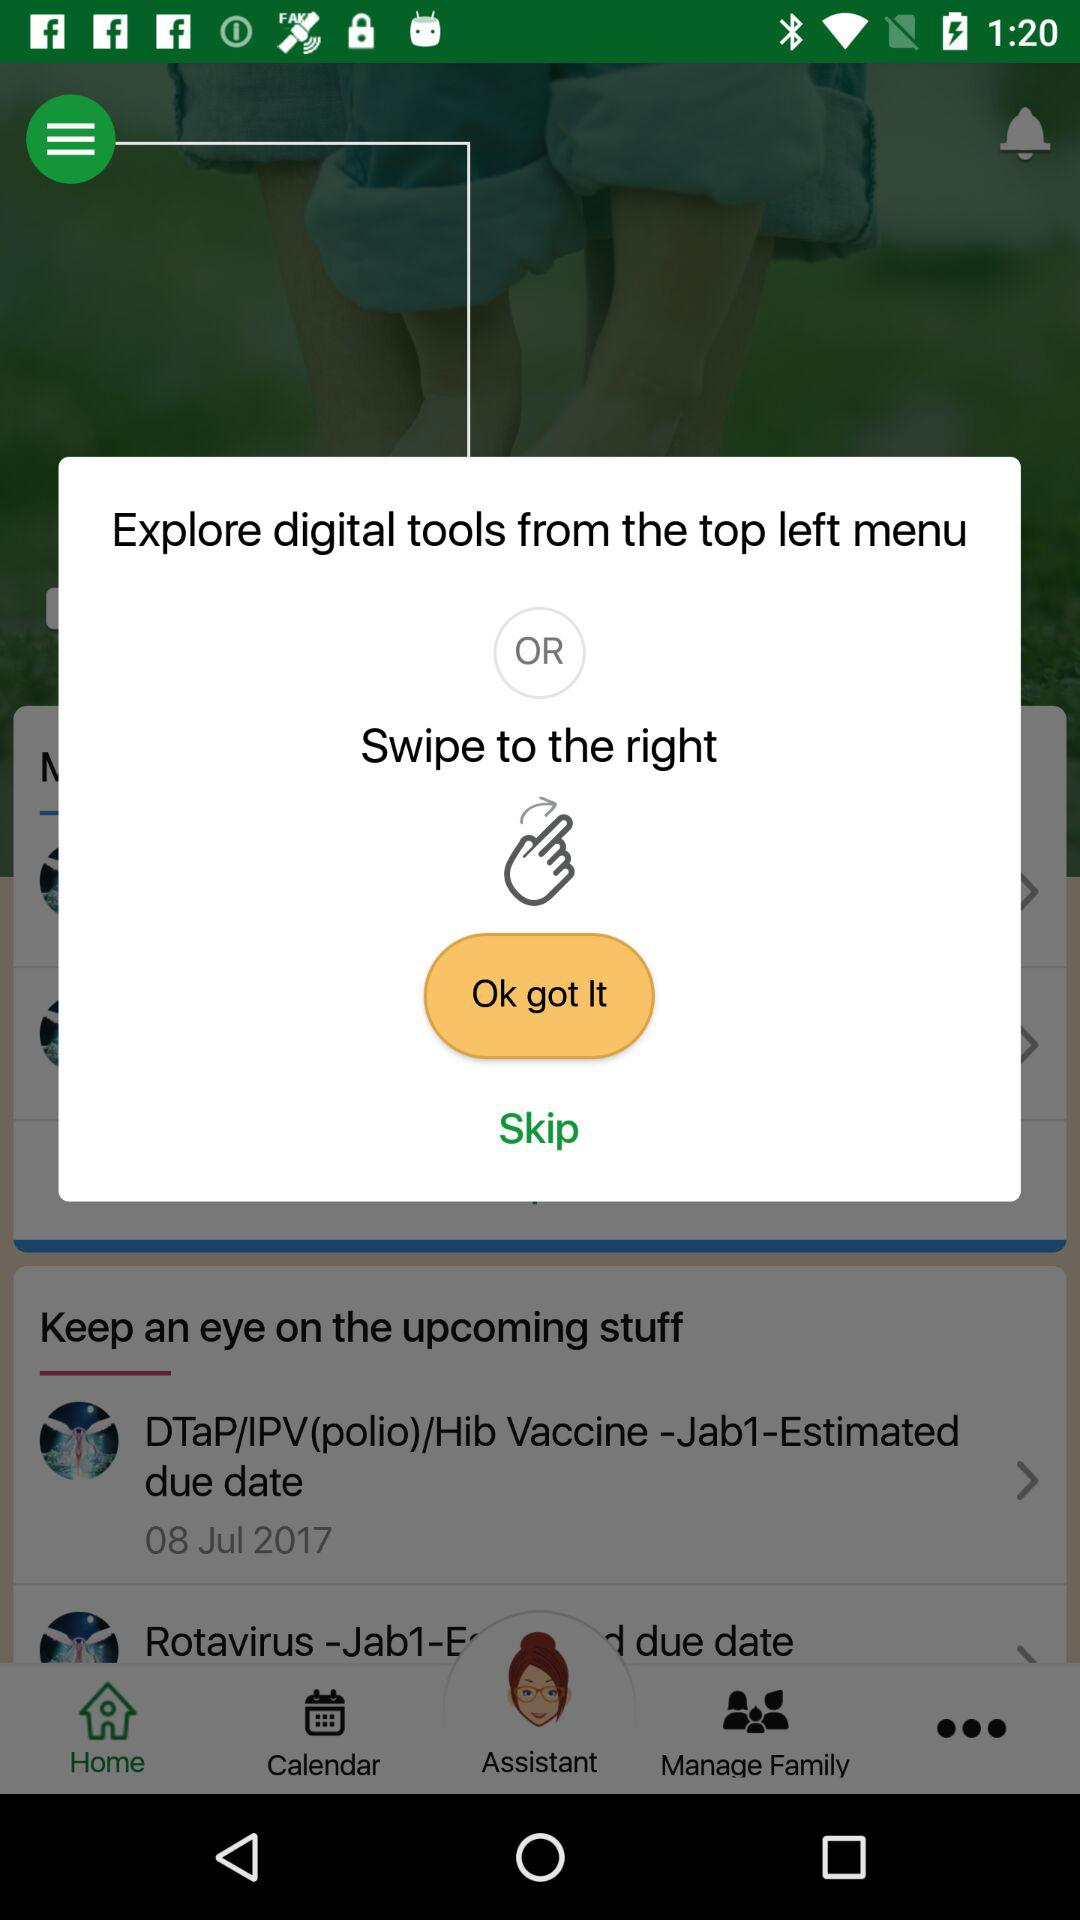What is the estimated due date of the "DTaP/IPV(polio)/Hib Vaccine -Jab1"? The estimated due date is July 8, 2017. 